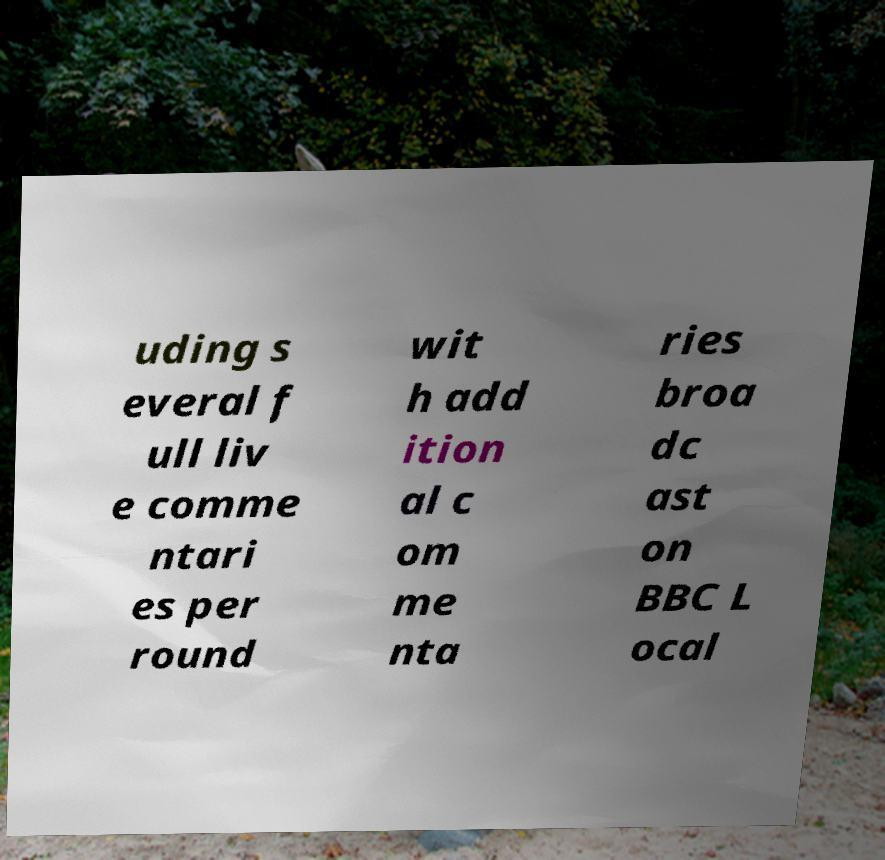Please identify and transcribe the text found in this image. uding s everal f ull liv e comme ntari es per round wit h add ition al c om me nta ries broa dc ast on BBC L ocal 